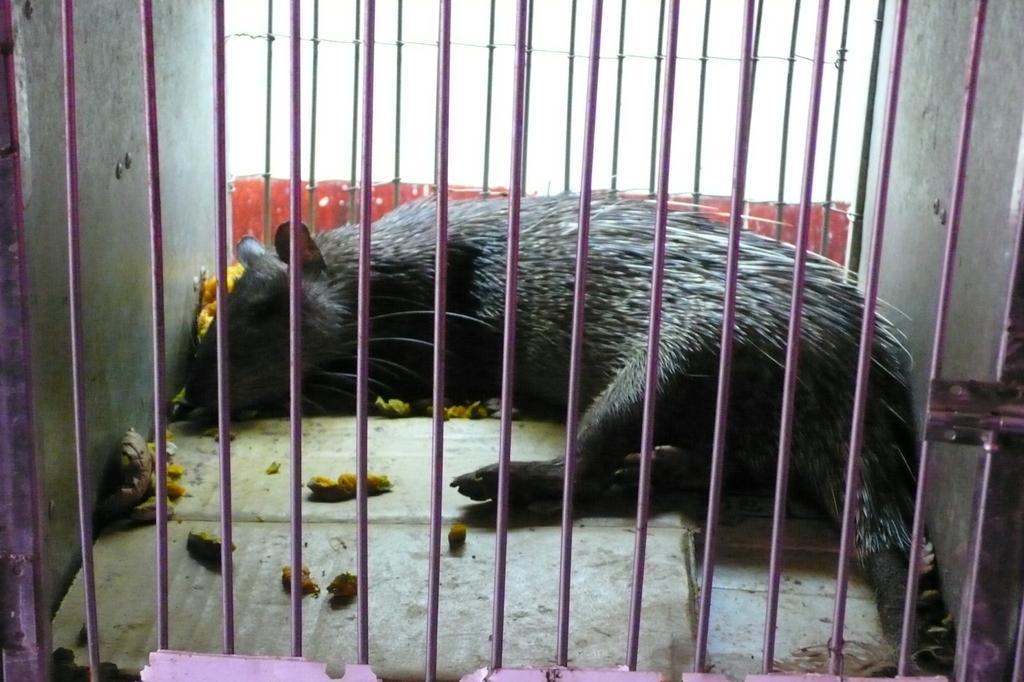In one or two sentences, can you explain what this image depicts? In this image we can see a rat in the cage and there are some things. 